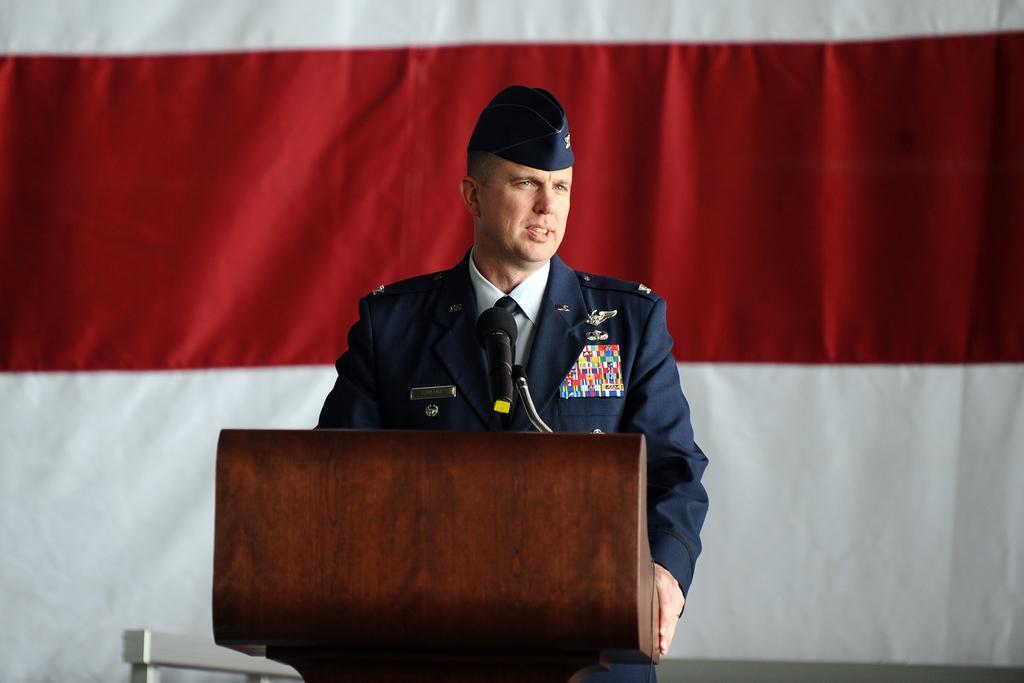In one or two sentences, can you explain what this image depicts? In the middle of the image there is a podium with a mic. Behind the podium there is a man standing with a hat on his head. Behind him there is a red and white background. 